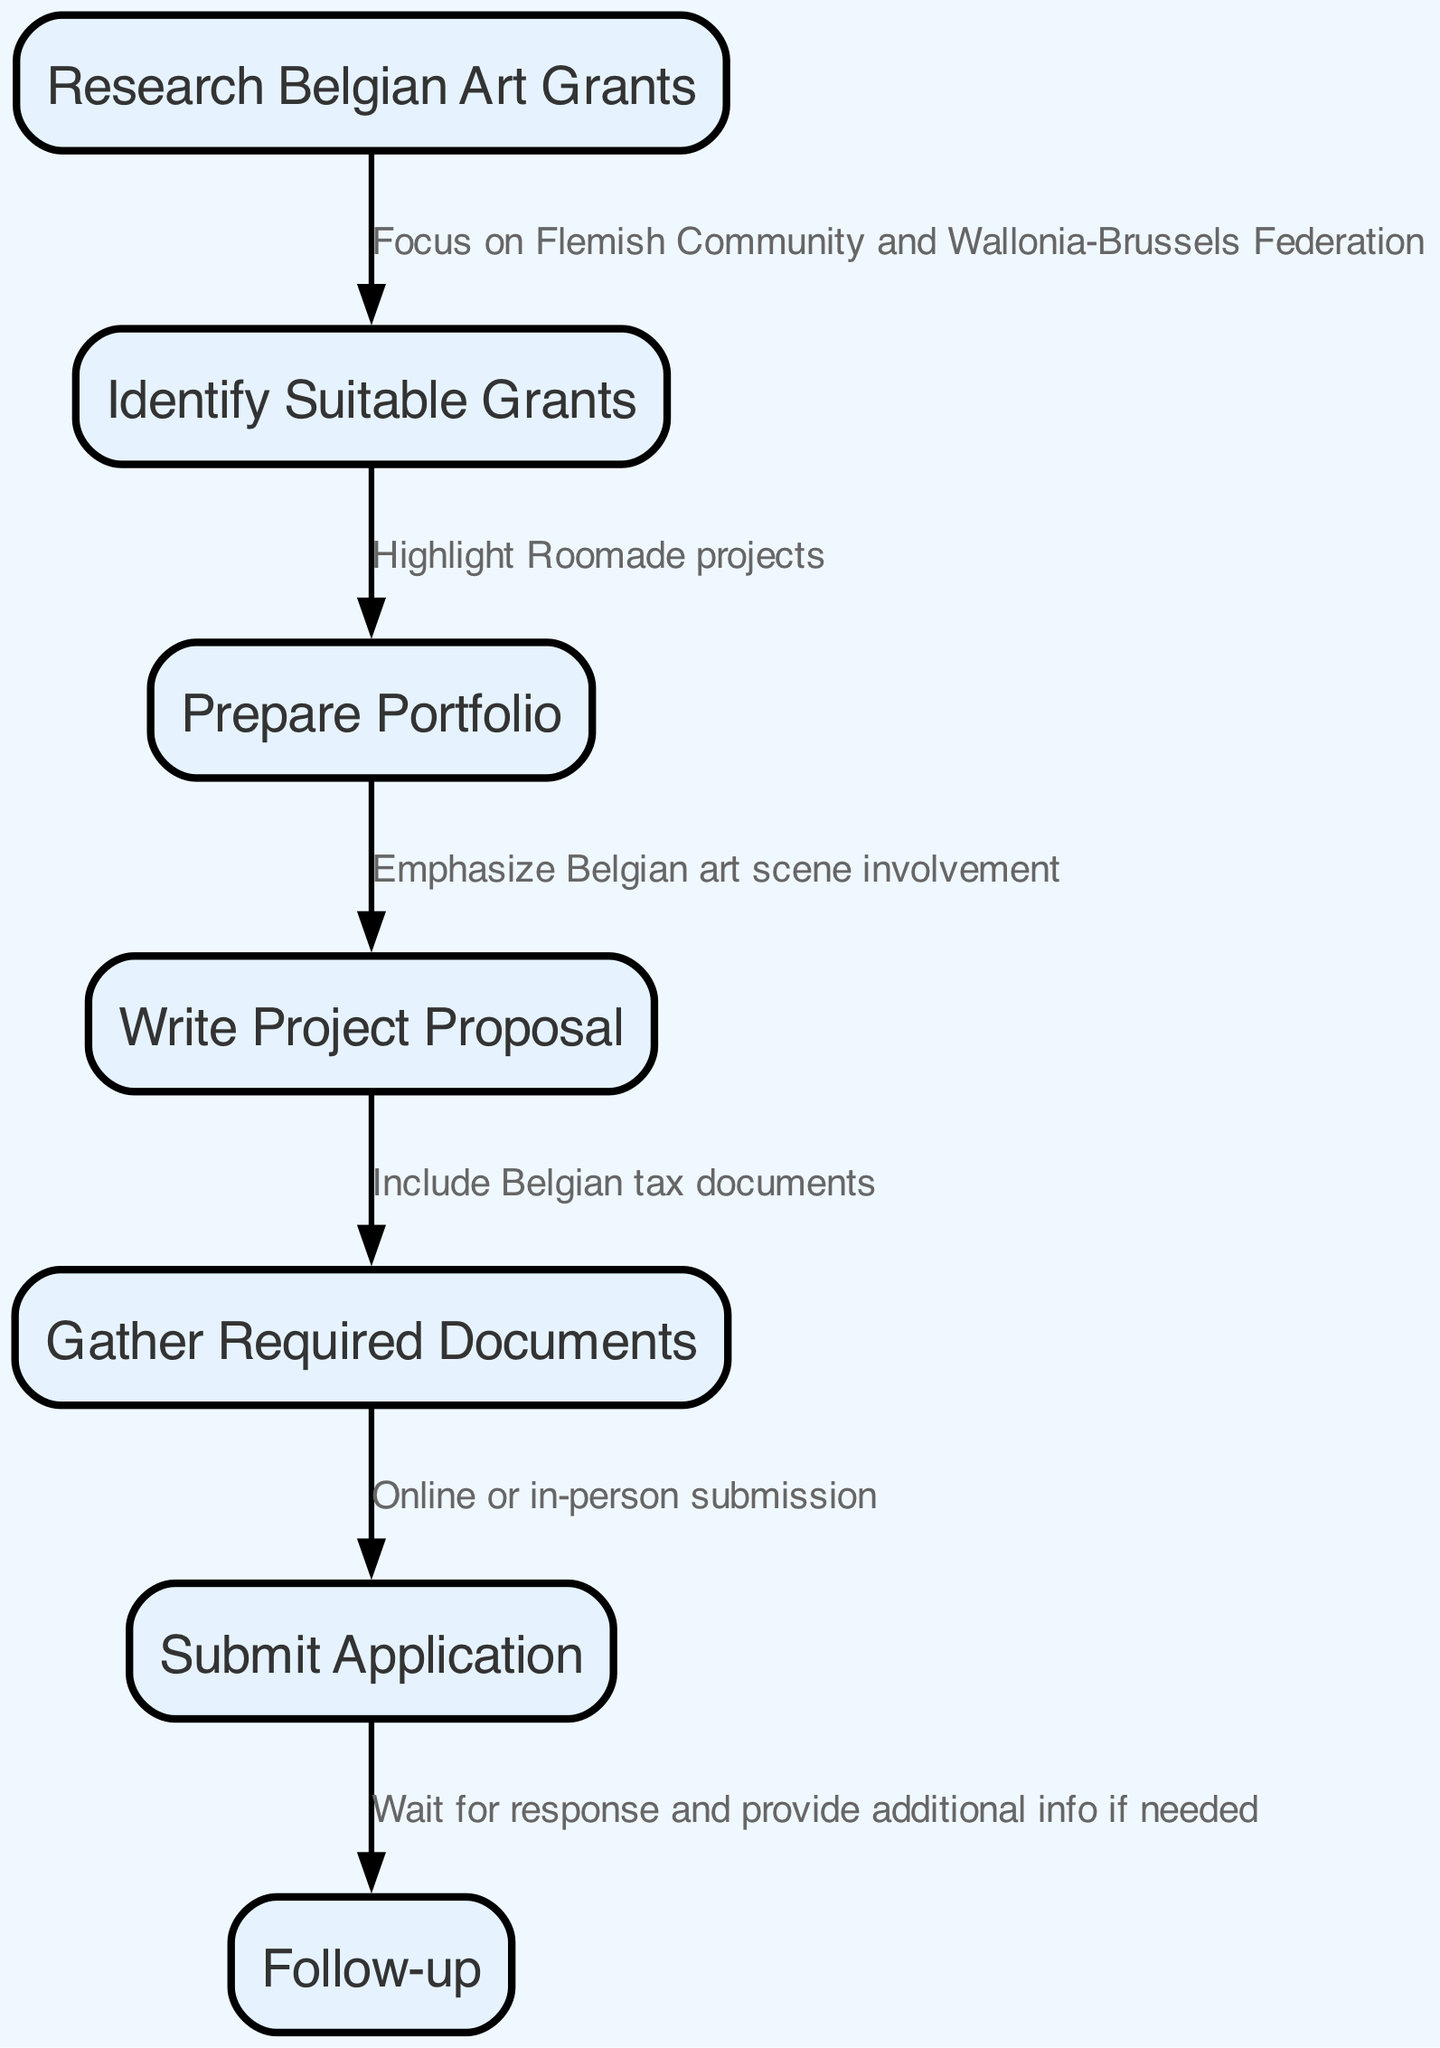What is the first step in the application process? The diagram starts with the node "Research Belgian Art Grants," which indicates that this is the first step in the application process.
Answer: Research Belgian Art Grants How many nodes are in the diagram? Counting all the nodes listed in the diagram, there are seven specific steps related to applying for art grants.
Answer: 7 What is emphasized in the project proposal preparation? The edge connecting "Prepare Portfolio" to "Write Project Proposal" mentions that one should emphasize involvement in the Belgian art scene during this preparation phase.
Answer: Emphasize Belgian art scene involvement What type of submission is mentioned in the diagram? The edge between "Gather Required Documents" and "Submit Application" specifies that submissions can be done either online or in-person.
Answer: Online or in-person submission What is the last step after submission? After the node "Submit Application," the following step is "Follow-up," indicating that this is the last step in the process.
Answer: Follow-up What do you need to include with the project proposal? The edge from "Write Project Proposal" to "Gather Required Documents" states that one should include Belgian tax documents alongside the proposal.
Answer: Belgian tax documents Which community focus is highlighted in the research stage? The edge from "Research Belgian Art Grants" to "Identify Suitable Grants" mentions focusing on the Flemish Community and Wallonia-Brussels Federation.
Answer: Flemish Community and Wallonia-Brussels Federation What information is required after submitting the application? The edge from "Submit Application" to "Follow-up" indicates that applicants should wait for a response and be ready to provide additional information if necessary.
Answer: Additional information if needed 